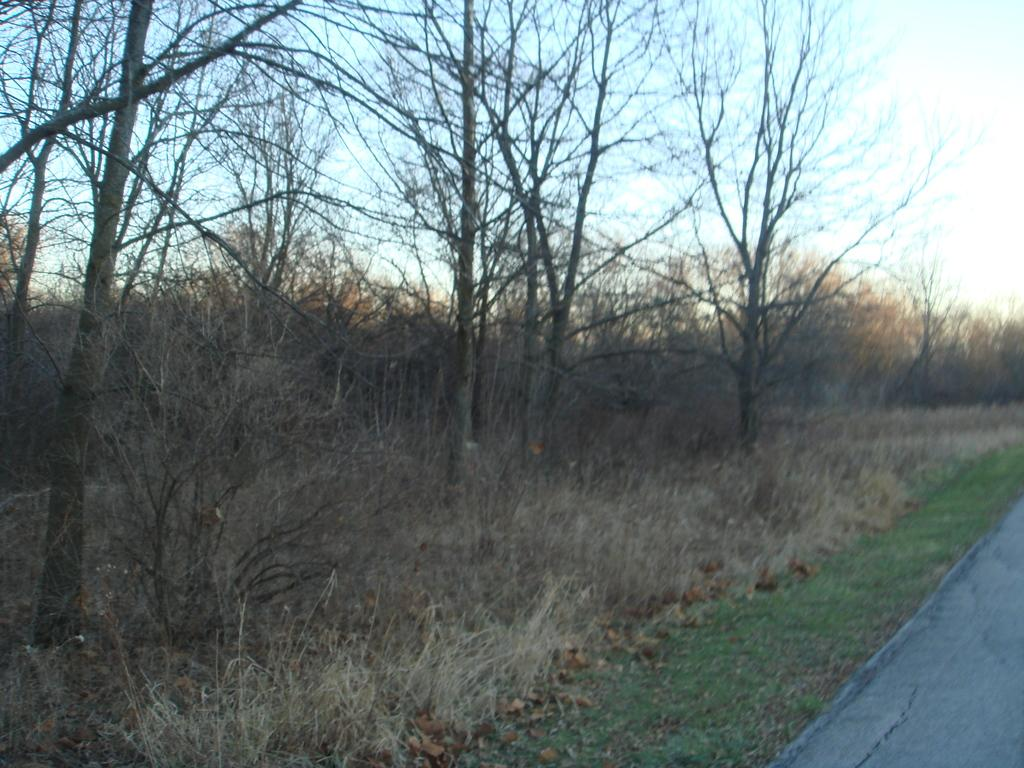What type of vegetation can be seen in the image? There is a group of trees, plants, and grass in the image. What kind of surface is present for walking or traveling? There is a pathway in the image. What is visible in the background of the image? The sky is visible in the image. How would you describe the sky's appearance in the image? The sky appears to be cloudy in the image. How many feet are visible in the image? There are no feet visible in the image. What type of structure can be seen in the image? There is no structure present in the image; it primarily features vegetation and a pathway. Is there any tin visible in the image? There is no tin present in the image. 